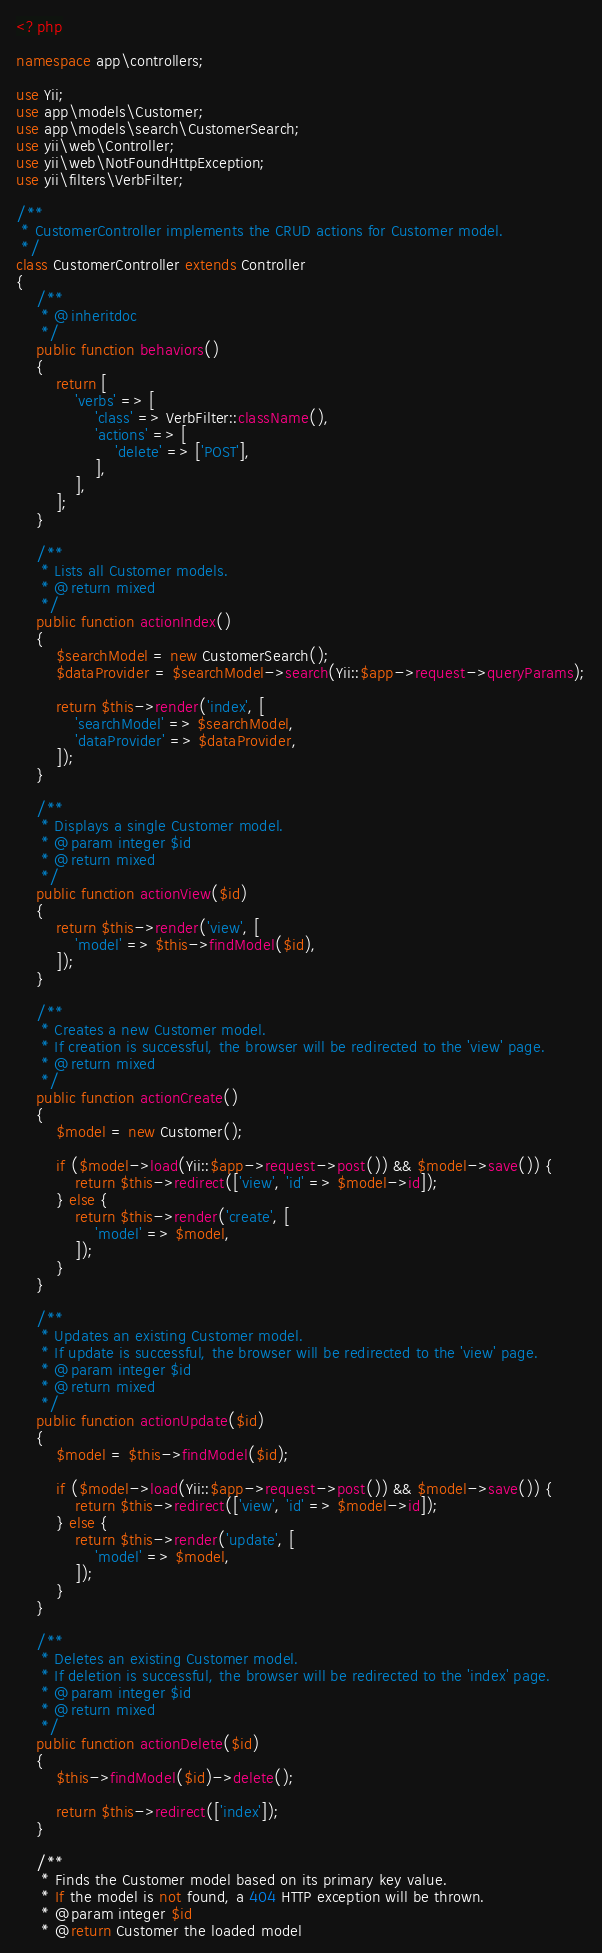Convert code to text. <code><loc_0><loc_0><loc_500><loc_500><_PHP_><?php

namespace app\controllers;

use Yii;
use app\models\Customer;
use app\models\search\CustomerSearch;
use yii\web\Controller;
use yii\web\NotFoundHttpException;
use yii\filters\VerbFilter;

/**
 * CustomerController implements the CRUD actions for Customer model.
 */
class CustomerController extends Controller
{
    /**
     * @inheritdoc
     */
    public function behaviors()
    {
        return [
            'verbs' => [
                'class' => VerbFilter::className(),
                'actions' => [
                    'delete' => ['POST'],
                ],
            ],
        ];
    }

    /**
     * Lists all Customer models.
     * @return mixed
     */
    public function actionIndex()
    {
        $searchModel = new CustomerSearch();
        $dataProvider = $searchModel->search(Yii::$app->request->queryParams);

        return $this->render('index', [
            'searchModel' => $searchModel,
            'dataProvider' => $dataProvider,
        ]);
    }

    /**
     * Displays a single Customer model.
     * @param integer $id
     * @return mixed
     */
    public function actionView($id)
    {
        return $this->render('view', [
            'model' => $this->findModel($id),
        ]);
    }

    /**
     * Creates a new Customer model.
     * If creation is successful, the browser will be redirected to the 'view' page.
     * @return mixed
     */
    public function actionCreate()
    {
        $model = new Customer();

        if ($model->load(Yii::$app->request->post()) && $model->save()) {
            return $this->redirect(['view', 'id' => $model->id]);
        } else {
            return $this->render('create', [
                'model' => $model,
            ]);
        }
    }

    /**
     * Updates an existing Customer model.
     * If update is successful, the browser will be redirected to the 'view' page.
     * @param integer $id
     * @return mixed
     */
    public function actionUpdate($id)
    {
        $model = $this->findModel($id);

        if ($model->load(Yii::$app->request->post()) && $model->save()) {
            return $this->redirect(['view', 'id' => $model->id]);
        } else {
            return $this->render('update', [
                'model' => $model,
            ]);
        }
    }

    /**
     * Deletes an existing Customer model.
     * If deletion is successful, the browser will be redirected to the 'index' page.
     * @param integer $id
     * @return mixed
     */
    public function actionDelete($id)
    {
        $this->findModel($id)->delete();

        return $this->redirect(['index']);
    }

    /**
     * Finds the Customer model based on its primary key value.
     * If the model is not found, a 404 HTTP exception will be thrown.
     * @param integer $id
     * @return Customer the loaded model</code> 